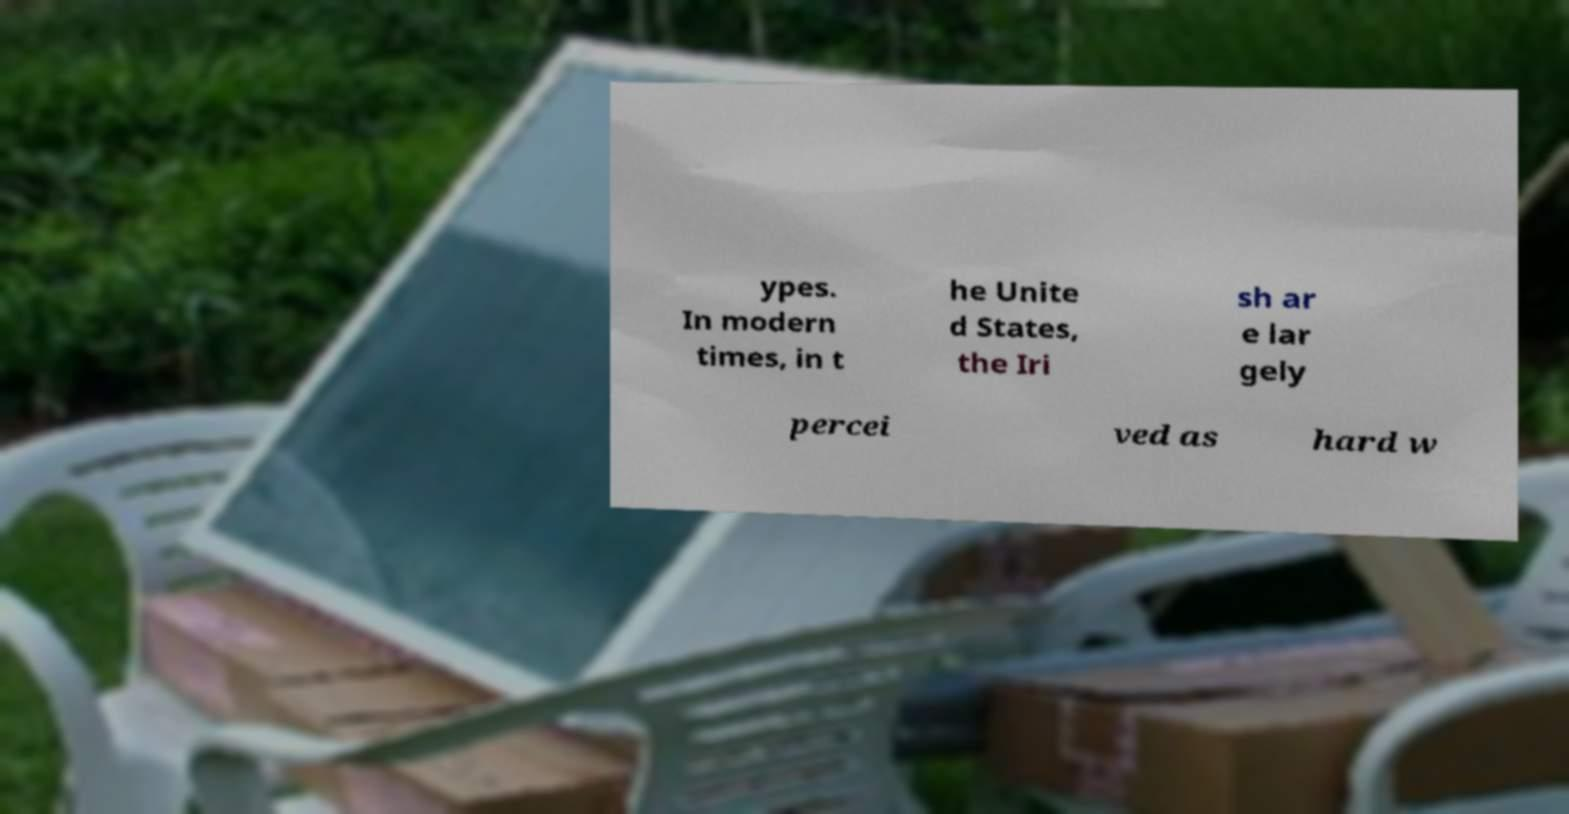There's text embedded in this image that I need extracted. Can you transcribe it verbatim? ypes. In modern times, in t he Unite d States, the Iri sh ar e lar gely percei ved as hard w 